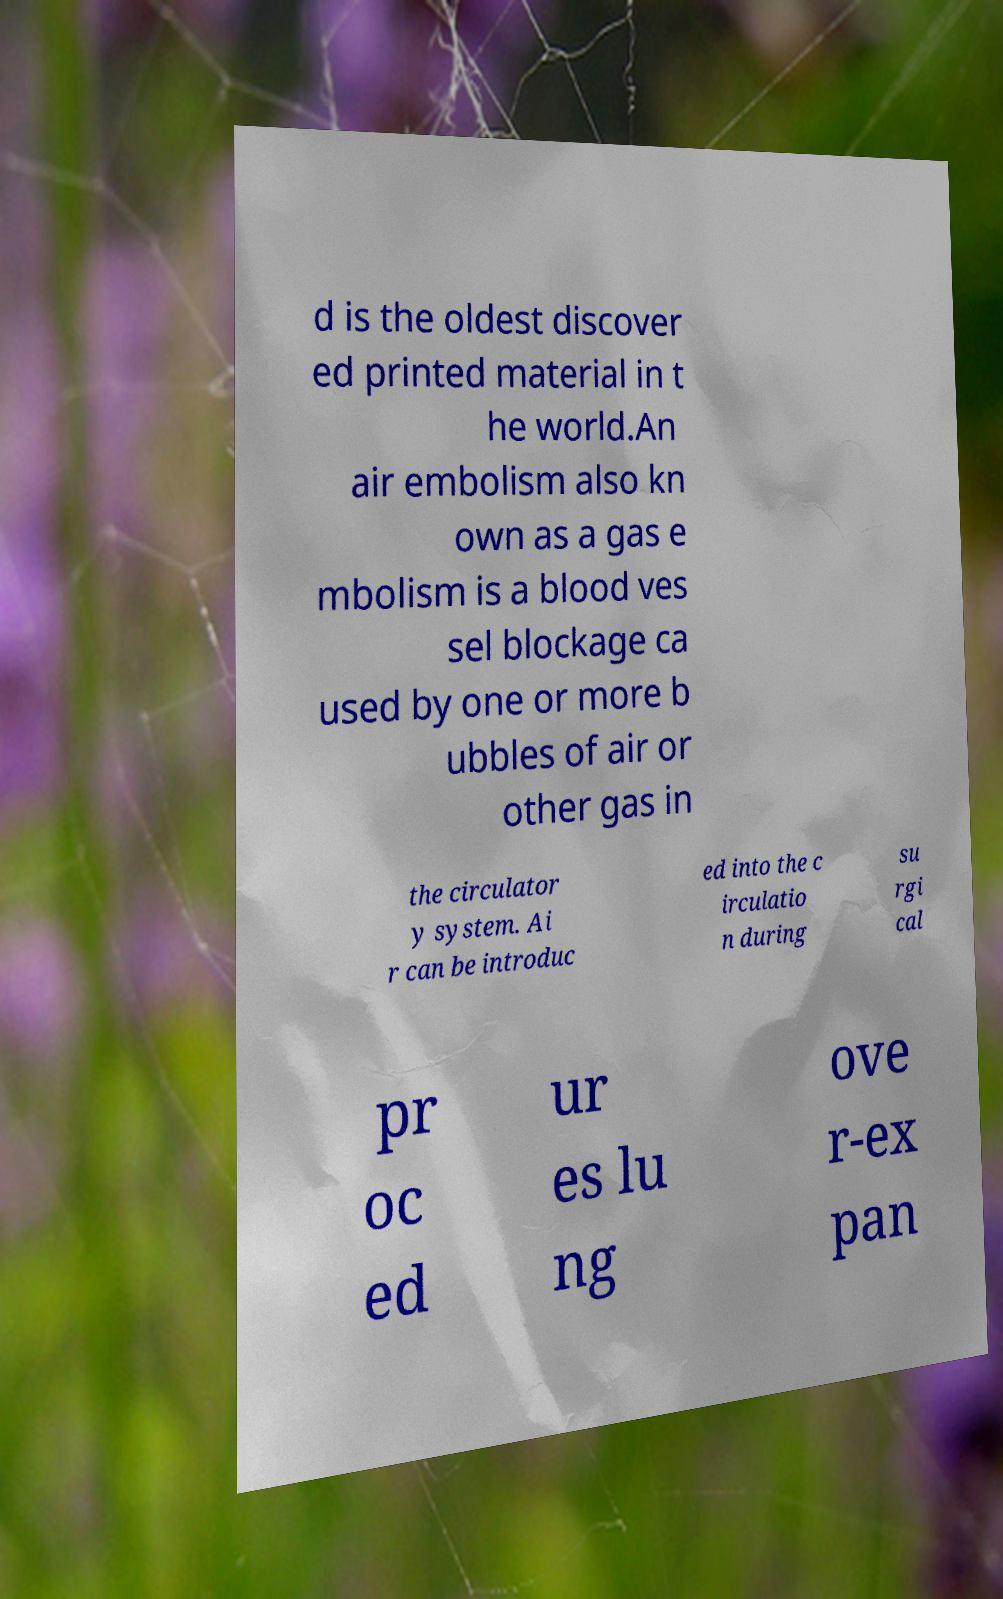What messages or text are displayed in this image? I need them in a readable, typed format. d is the oldest discover ed printed material in t he world.An air embolism also kn own as a gas e mbolism is a blood ves sel blockage ca used by one or more b ubbles of air or other gas in the circulator y system. Ai r can be introduc ed into the c irculatio n during su rgi cal pr oc ed ur es lu ng ove r-ex pan 